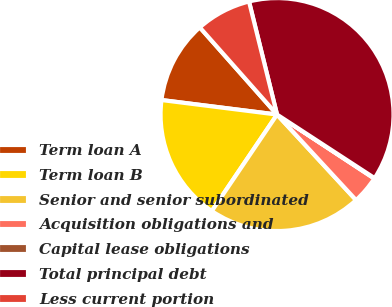Convert chart to OTSL. <chart><loc_0><loc_0><loc_500><loc_500><pie_chart><fcel>Term loan A<fcel>Term loan B<fcel>Senior and senior subordinated<fcel>Acquisition obligations and<fcel>Capital lease obligations<fcel>Total principal debt<fcel>Less current portion<nl><fcel>11.47%<fcel>17.53%<fcel>21.33%<fcel>3.87%<fcel>0.07%<fcel>38.06%<fcel>7.67%<nl></chart> 